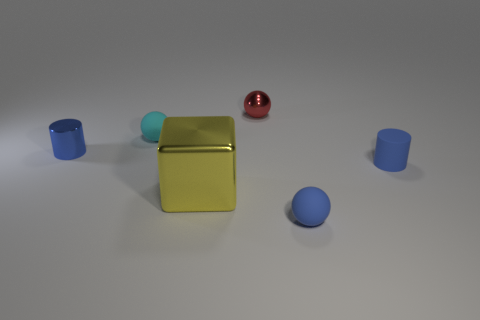Add 3 matte objects. How many objects exist? 9 Subtract all cylinders. How many objects are left? 4 Add 1 blue balls. How many blue balls are left? 2 Add 1 big green rubber objects. How many big green rubber objects exist? 1 Subtract all blue spheres. How many spheres are left? 2 Subtract 0 brown spheres. How many objects are left? 6 Subtract all cyan cylinders. Subtract all green blocks. How many cylinders are left? 2 Subtract all blue cylinders. How many red spheres are left? 1 Subtract all small brown matte balls. Subtract all yellow metal objects. How many objects are left? 5 